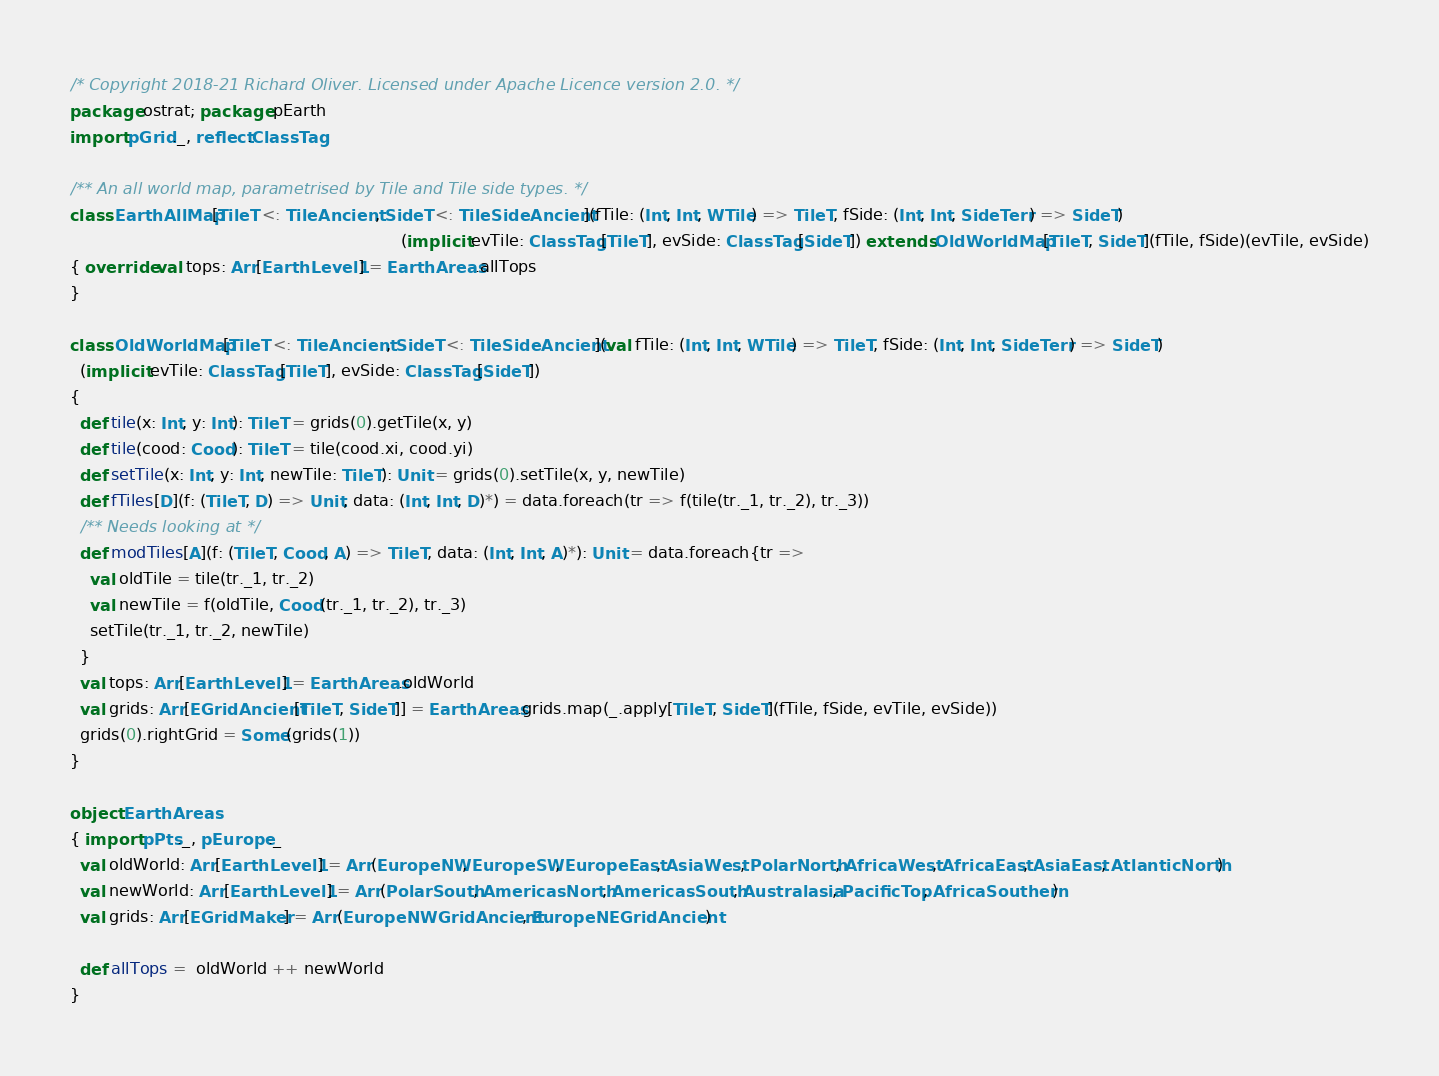Convert code to text. <code><loc_0><loc_0><loc_500><loc_500><_Scala_>/* Copyright 2018-21 Richard Oliver. Licensed under Apache Licence version 2.0. */
package ostrat; package pEarth
import pGrid._, reflect.ClassTag

/** An all world map, parametrised by Tile and Tile side types. */
class EarthAllMap[TileT <: TileAncient, SideT <: TileSideAncient](fTile: (Int, Int, WTile) => TileT, fSide: (Int, Int, SideTerr) => SideT)
                                                                 (implicit evTile: ClassTag[TileT], evSide: ClassTag[SideT]) extends OldWorldMap[TileT, SideT](fTile, fSide)(evTile, evSide)
{ override val tops: Arr[EarthLevel1] = EarthAreas.allTops
}

class OldWorldMap[TileT <: TileAncient, SideT <: TileSideAncient](val fTile: (Int, Int, WTile) => TileT, fSide: (Int, Int, SideTerr) => SideT)
  (implicit evTile: ClassTag[TileT], evSide: ClassTag[SideT])
{
  def tile(x: Int, y: Int): TileT = grids(0).getTile(x, y)
  def tile(cood: Cood): TileT = tile(cood.xi, cood.yi)
  def setTile(x: Int, y: Int, newTile: TileT): Unit = grids(0).setTile(x, y, newTile)
  def fTiles[D](f: (TileT, D) => Unit, data: (Int, Int, D)*) = data.foreach(tr => f(tile(tr._1, tr._2), tr._3))
  /** Needs looking at */
  def modTiles[A](f: (TileT, Cood, A) => TileT, data: (Int, Int, A)*): Unit = data.foreach{tr =>
    val oldTile = tile(tr._1, tr._2)
    val newTile = f(oldTile, Cood(tr._1, tr._2), tr._3)
    setTile(tr._1, tr._2, newTile)
  }
  val tops: Arr[EarthLevel1] = EarthAreas.oldWorld
  val grids: Arr[EGridAncient[TileT, SideT]] = EarthAreas.grids.map(_.apply[TileT, SideT](fTile, fSide, evTile, evSide))
  grids(0).rightGrid = Some(grids(1))
}

object EarthAreas
{ import pPts._, pEurope._
  val oldWorld: Arr[EarthLevel1] = Arr(EuropeNW, EuropeSW, EuropeEast, AsiaWest, PolarNorth, AfricaWest, AfricaEast, AsiaEast, AtlanticNorth)
  val newWorld: Arr[EarthLevel1] = Arr(PolarSouth, AmericasNorth, AmericasSouth, Australasia, PacificTop, AfricaSouthern)
  val grids: Arr[EGridMaker] = Arr(EuropeNWGridAncient, EuropeNEGridAncient)

  def allTops =  oldWorld ++ newWorld
}</code> 